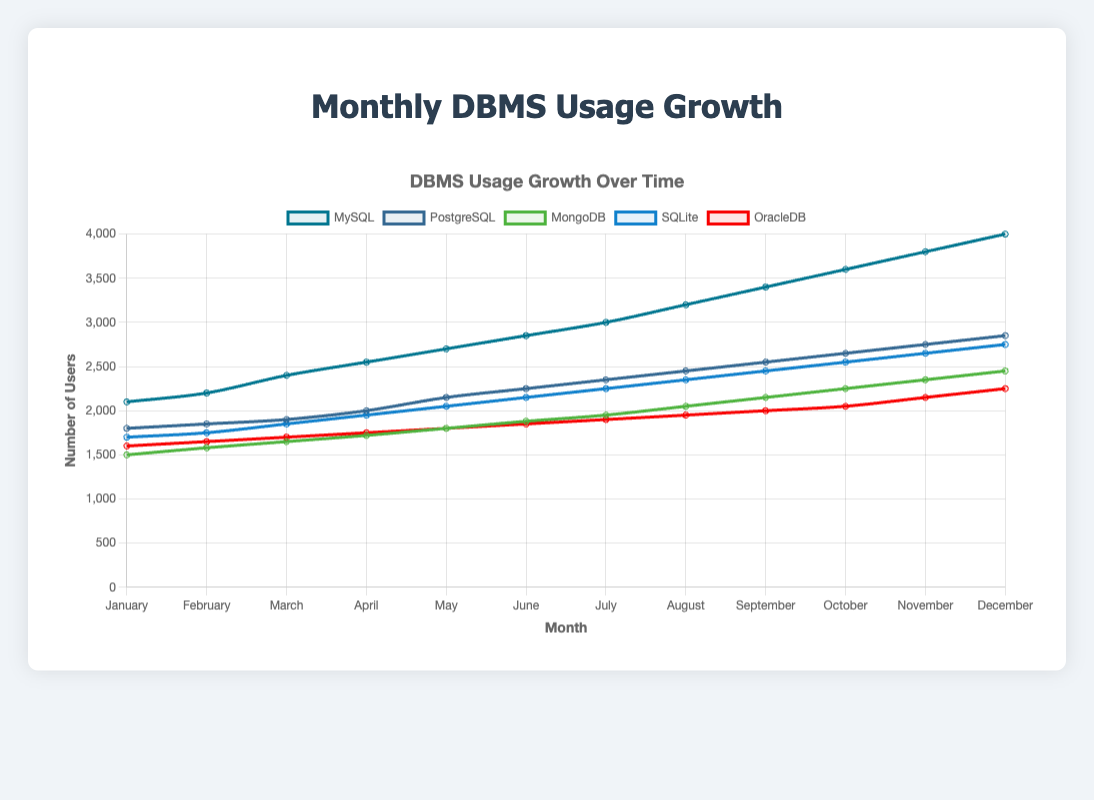Which database management system had the highest number of users in December? By observing the trend lines in December, MySQL has the highest number of users at 4000.
Answer: MySQL Which month shows the greatest increase in the number of users for PostgreSQL? Compare the increment of PostgreSQL users from month to month. The largest jump is from May (2150 users) to June (2250 users), an increase of 100 users.
Answer: June What is the total number of users for MongoDB across the entire year? Sum the number of users for MongoDB for each month: 1500 + 1580 + 1650 + 1720 + 1800 + 1880 + 1950 + 2050 + 2150 + 2250 + 2350 + 2450 = 24330
Answer: 24330 Which DBMS had a more consistent growth: MySQL or PostgreSQL? Observe the trend lines for MySQL and PostgreSQL. MySQL has a smoother and more consistent upward trend while PostgreSQL has more fluctuations.
Answer: MySQL During which month did SQLite first exceed 2000 users? Find the first month where SQLite’s user count is above 2000. For SQLite, it first exceeds 2000 users in May (2050).
Answer: May What is the difference in the number of users between MySQL and OracleDB in October? MySQL had 3600 users and OracleDB had 2050 users in October. The difference is 3600 - 2050 = 1550.
Answer: 1550 How many months did it take for MongoDB to reach at least 2000 users? Track MongoDB's user growth. It reached 2000 users for the first time in August.
Answer: 8 months In which months did PostgreSQL have fewer than 2000 users? PostgreSQL had fewer than 2000 users from January to March: 1800 in January, 1850 in February, 1900 in March.
Answer: January, February, March What is the average number of users for OracleDB across the year? Calculate the average of OracleDB users: (1600 + 1650 + 1700 + 1750 + 1800 + 1850 + 1900 + 1950 + 2000 + 2050 + 2150 + 2250) / 12 = 1879
Answer: 1879 Which DBMS showed the greatest percentage growth from January to December? Calculate the percentage growth for each DBMS. MySQL grew from 2100 to 4000 which is a (4000-2100)/2100 * 100% ≈ 90%, PostgreSQL grew but not as much as MySQL. Similar calculation for other DBMS shows MySQL had the highest percentage growth.
Answer: MySQL 